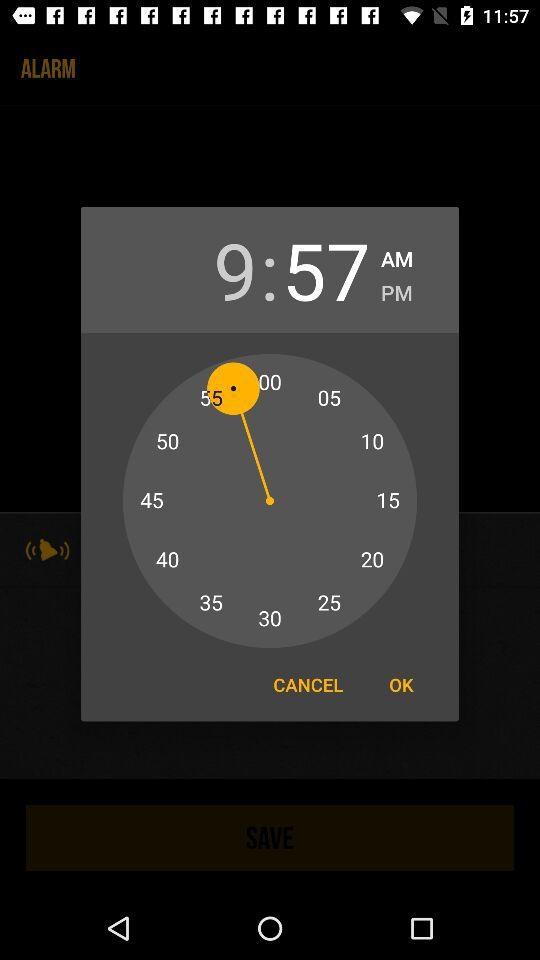What is the set time? The set time is 9:57 AM. 